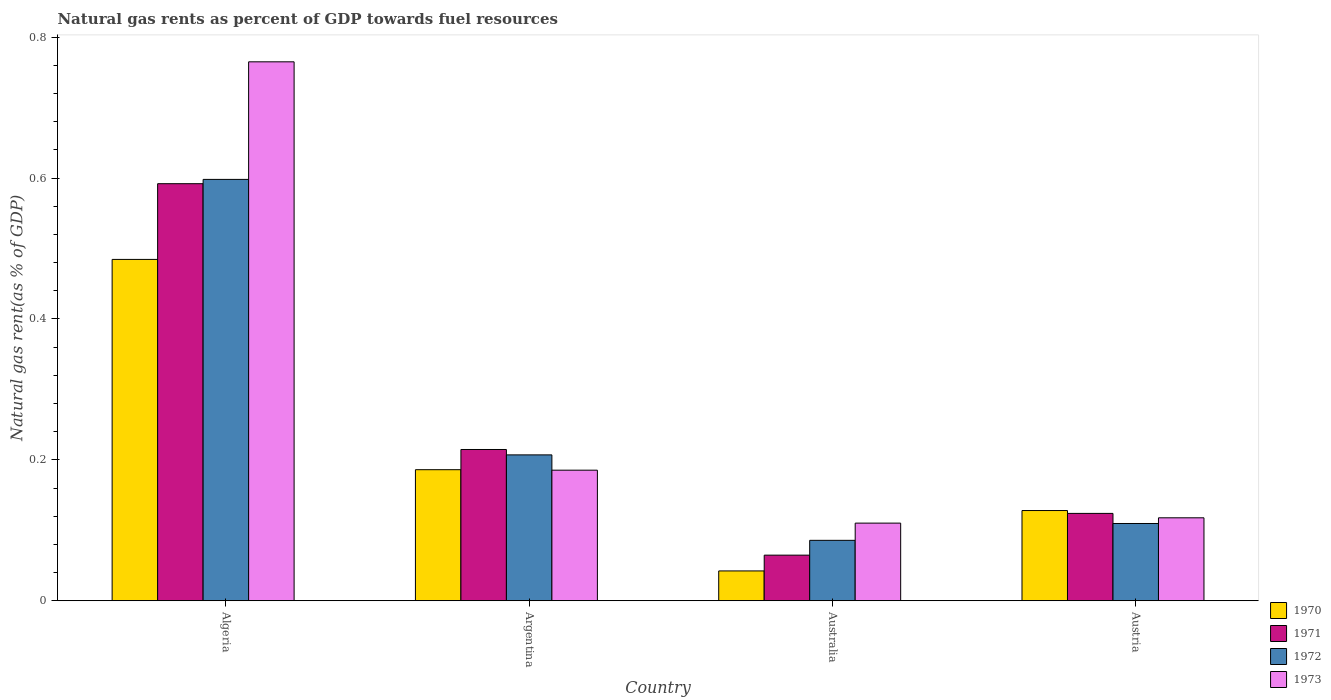Are the number of bars on each tick of the X-axis equal?
Provide a succinct answer. Yes. How many bars are there on the 2nd tick from the left?
Offer a very short reply. 4. What is the label of the 2nd group of bars from the left?
Keep it short and to the point. Argentina. What is the natural gas rent in 1972 in Austria?
Give a very brief answer. 0.11. Across all countries, what is the maximum natural gas rent in 1970?
Your answer should be compact. 0.48. Across all countries, what is the minimum natural gas rent in 1971?
Ensure brevity in your answer.  0.06. In which country was the natural gas rent in 1971 maximum?
Provide a short and direct response. Algeria. What is the total natural gas rent in 1971 in the graph?
Offer a very short reply. 1. What is the difference between the natural gas rent in 1971 in Argentina and that in Australia?
Offer a very short reply. 0.15. What is the difference between the natural gas rent in 1972 in Australia and the natural gas rent in 1970 in Austria?
Your answer should be compact. -0.04. What is the average natural gas rent in 1973 per country?
Your answer should be compact. 0.29. What is the difference between the natural gas rent of/in 1973 and natural gas rent of/in 1971 in Australia?
Offer a very short reply. 0.05. What is the ratio of the natural gas rent in 1972 in Argentina to that in Austria?
Keep it short and to the point. 1.89. Is the natural gas rent in 1972 in Argentina less than that in Austria?
Offer a terse response. No. What is the difference between the highest and the second highest natural gas rent in 1973?
Your answer should be very brief. 0.58. What is the difference between the highest and the lowest natural gas rent in 1970?
Provide a succinct answer. 0.44. In how many countries, is the natural gas rent in 1971 greater than the average natural gas rent in 1971 taken over all countries?
Provide a succinct answer. 1. Is the sum of the natural gas rent in 1970 in Algeria and Argentina greater than the maximum natural gas rent in 1972 across all countries?
Offer a very short reply. Yes. Is it the case that in every country, the sum of the natural gas rent in 1971 and natural gas rent in 1973 is greater than the sum of natural gas rent in 1972 and natural gas rent in 1970?
Your response must be concise. No. Is it the case that in every country, the sum of the natural gas rent in 1973 and natural gas rent in 1972 is greater than the natural gas rent in 1971?
Offer a very short reply. Yes. Are all the bars in the graph horizontal?
Provide a short and direct response. No. What is the difference between two consecutive major ticks on the Y-axis?
Provide a short and direct response. 0.2. Does the graph contain any zero values?
Offer a terse response. No. Does the graph contain grids?
Ensure brevity in your answer.  No. Where does the legend appear in the graph?
Provide a short and direct response. Bottom right. What is the title of the graph?
Ensure brevity in your answer.  Natural gas rents as percent of GDP towards fuel resources. What is the label or title of the Y-axis?
Your response must be concise. Natural gas rent(as % of GDP). What is the Natural gas rent(as % of GDP) of 1970 in Algeria?
Provide a short and direct response. 0.48. What is the Natural gas rent(as % of GDP) in 1971 in Algeria?
Your response must be concise. 0.59. What is the Natural gas rent(as % of GDP) in 1972 in Algeria?
Offer a terse response. 0.6. What is the Natural gas rent(as % of GDP) in 1973 in Algeria?
Your answer should be very brief. 0.76. What is the Natural gas rent(as % of GDP) in 1970 in Argentina?
Provide a short and direct response. 0.19. What is the Natural gas rent(as % of GDP) of 1971 in Argentina?
Offer a terse response. 0.21. What is the Natural gas rent(as % of GDP) of 1972 in Argentina?
Make the answer very short. 0.21. What is the Natural gas rent(as % of GDP) in 1973 in Argentina?
Offer a very short reply. 0.19. What is the Natural gas rent(as % of GDP) in 1970 in Australia?
Offer a very short reply. 0.04. What is the Natural gas rent(as % of GDP) of 1971 in Australia?
Ensure brevity in your answer.  0.06. What is the Natural gas rent(as % of GDP) in 1972 in Australia?
Make the answer very short. 0.09. What is the Natural gas rent(as % of GDP) of 1973 in Australia?
Provide a short and direct response. 0.11. What is the Natural gas rent(as % of GDP) in 1970 in Austria?
Your answer should be compact. 0.13. What is the Natural gas rent(as % of GDP) of 1971 in Austria?
Your response must be concise. 0.12. What is the Natural gas rent(as % of GDP) of 1972 in Austria?
Offer a very short reply. 0.11. What is the Natural gas rent(as % of GDP) in 1973 in Austria?
Your response must be concise. 0.12. Across all countries, what is the maximum Natural gas rent(as % of GDP) in 1970?
Your response must be concise. 0.48. Across all countries, what is the maximum Natural gas rent(as % of GDP) in 1971?
Offer a terse response. 0.59. Across all countries, what is the maximum Natural gas rent(as % of GDP) of 1972?
Your answer should be very brief. 0.6. Across all countries, what is the maximum Natural gas rent(as % of GDP) in 1973?
Provide a succinct answer. 0.76. Across all countries, what is the minimum Natural gas rent(as % of GDP) of 1970?
Give a very brief answer. 0.04. Across all countries, what is the minimum Natural gas rent(as % of GDP) of 1971?
Ensure brevity in your answer.  0.06. Across all countries, what is the minimum Natural gas rent(as % of GDP) of 1972?
Offer a terse response. 0.09. Across all countries, what is the minimum Natural gas rent(as % of GDP) in 1973?
Keep it short and to the point. 0.11. What is the total Natural gas rent(as % of GDP) of 1970 in the graph?
Provide a short and direct response. 0.84. What is the total Natural gas rent(as % of GDP) of 1971 in the graph?
Offer a very short reply. 1. What is the total Natural gas rent(as % of GDP) in 1973 in the graph?
Make the answer very short. 1.18. What is the difference between the Natural gas rent(as % of GDP) of 1970 in Algeria and that in Argentina?
Provide a short and direct response. 0.3. What is the difference between the Natural gas rent(as % of GDP) in 1971 in Algeria and that in Argentina?
Provide a succinct answer. 0.38. What is the difference between the Natural gas rent(as % of GDP) in 1972 in Algeria and that in Argentina?
Offer a terse response. 0.39. What is the difference between the Natural gas rent(as % of GDP) of 1973 in Algeria and that in Argentina?
Offer a terse response. 0.58. What is the difference between the Natural gas rent(as % of GDP) of 1970 in Algeria and that in Australia?
Provide a succinct answer. 0.44. What is the difference between the Natural gas rent(as % of GDP) in 1971 in Algeria and that in Australia?
Your response must be concise. 0.53. What is the difference between the Natural gas rent(as % of GDP) of 1972 in Algeria and that in Australia?
Your response must be concise. 0.51. What is the difference between the Natural gas rent(as % of GDP) in 1973 in Algeria and that in Australia?
Keep it short and to the point. 0.65. What is the difference between the Natural gas rent(as % of GDP) of 1970 in Algeria and that in Austria?
Give a very brief answer. 0.36. What is the difference between the Natural gas rent(as % of GDP) in 1971 in Algeria and that in Austria?
Provide a short and direct response. 0.47. What is the difference between the Natural gas rent(as % of GDP) of 1972 in Algeria and that in Austria?
Offer a very short reply. 0.49. What is the difference between the Natural gas rent(as % of GDP) of 1973 in Algeria and that in Austria?
Provide a succinct answer. 0.65. What is the difference between the Natural gas rent(as % of GDP) of 1970 in Argentina and that in Australia?
Your answer should be compact. 0.14. What is the difference between the Natural gas rent(as % of GDP) in 1971 in Argentina and that in Australia?
Keep it short and to the point. 0.15. What is the difference between the Natural gas rent(as % of GDP) of 1972 in Argentina and that in Australia?
Keep it short and to the point. 0.12. What is the difference between the Natural gas rent(as % of GDP) in 1973 in Argentina and that in Australia?
Offer a terse response. 0.08. What is the difference between the Natural gas rent(as % of GDP) of 1970 in Argentina and that in Austria?
Your response must be concise. 0.06. What is the difference between the Natural gas rent(as % of GDP) of 1971 in Argentina and that in Austria?
Provide a short and direct response. 0.09. What is the difference between the Natural gas rent(as % of GDP) of 1972 in Argentina and that in Austria?
Your response must be concise. 0.1. What is the difference between the Natural gas rent(as % of GDP) of 1973 in Argentina and that in Austria?
Offer a terse response. 0.07. What is the difference between the Natural gas rent(as % of GDP) of 1970 in Australia and that in Austria?
Ensure brevity in your answer.  -0.09. What is the difference between the Natural gas rent(as % of GDP) in 1971 in Australia and that in Austria?
Give a very brief answer. -0.06. What is the difference between the Natural gas rent(as % of GDP) of 1972 in Australia and that in Austria?
Your response must be concise. -0.02. What is the difference between the Natural gas rent(as % of GDP) in 1973 in Australia and that in Austria?
Offer a very short reply. -0.01. What is the difference between the Natural gas rent(as % of GDP) of 1970 in Algeria and the Natural gas rent(as % of GDP) of 1971 in Argentina?
Provide a short and direct response. 0.27. What is the difference between the Natural gas rent(as % of GDP) in 1970 in Algeria and the Natural gas rent(as % of GDP) in 1972 in Argentina?
Offer a terse response. 0.28. What is the difference between the Natural gas rent(as % of GDP) of 1970 in Algeria and the Natural gas rent(as % of GDP) of 1973 in Argentina?
Your response must be concise. 0.3. What is the difference between the Natural gas rent(as % of GDP) in 1971 in Algeria and the Natural gas rent(as % of GDP) in 1972 in Argentina?
Give a very brief answer. 0.38. What is the difference between the Natural gas rent(as % of GDP) of 1971 in Algeria and the Natural gas rent(as % of GDP) of 1973 in Argentina?
Provide a succinct answer. 0.41. What is the difference between the Natural gas rent(as % of GDP) of 1972 in Algeria and the Natural gas rent(as % of GDP) of 1973 in Argentina?
Provide a short and direct response. 0.41. What is the difference between the Natural gas rent(as % of GDP) in 1970 in Algeria and the Natural gas rent(as % of GDP) in 1971 in Australia?
Give a very brief answer. 0.42. What is the difference between the Natural gas rent(as % of GDP) in 1970 in Algeria and the Natural gas rent(as % of GDP) in 1972 in Australia?
Provide a short and direct response. 0.4. What is the difference between the Natural gas rent(as % of GDP) in 1970 in Algeria and the Natural gas rent(as % of GDP) in 1973 in Australia?
Your answer should be very brief. 0.37. What is the difference between the Natural gas rent(as % of GDP) in 1971 in Algeria and the Natural gas rent(as % of GDP) in 1972 in Australia?
Provide a short and direct response. 0.51. What is the difference between the Natural gas rent(as % of GDP) of 1971 in Algeria and the Natural gas rent(as % of GDP) of 1973 in Australia?
Provide a succinct answer. 0.48. What is the difference between the Natural gas rent(as % of GDP) of 1972 in Algeria and the Natural gas rent(as % of GDP) of 1973 in Australia?
Make the answer very short. 0.49. What is the difference between the Natural gas rent(as % of GDP) in 1970 in Algeria and the Natural gas rent(as % of GDP) in 1971 in Austria?
Make the answer very short. 0.36. What is the difference between the Natural gas rent(as % of GDP) of 1970 in Algeria and the Natural gas rent(as % of GDP) of 1972 in Austria?
Ensure brevity in your answer.  0.37. What is the difference between the Natural gas rent(as % of GDP) in 1970 in Algeria and the Natural gas rent(as % of GDP) in 1973 in Austria?
Give a very brief answer. 0.37. What is the difference between the Natural gas rent(as % of GDP) of 1971 in Algeria and the Natural gas rent(as % of GDP) of 1972 in Austria?
Give a very brief answer. 0.48. What is the difference between the Natural gas rent(as % of GDP) of 1971 in Algeria and the Natural gas rent(as % of GDP) of 1973 in Austria?
Ensure brevity in your answer.  0.47. What is the difference between the Natural gas rent(as % of GDP) of 1972 in Algeria and the Natural gas rent(as % of GDP) of 1973 in Austria?
Provide a short and direct response. 0.48. What is the difference between the Natural gas rent(as % of GDP) of 1970 in Argentina and the Natural gas rent(as % of GDP) of 1971 in Australia?
Offer a very short reply. 0.12. What is the difference between the Natural gas rent(as % of GDP) in 1970 in Argentina and the Natural gas rent(as % of GDP) in 1972 in Australia?
Make the answer very short. 0.1. What is the difference between the Natural gas rent(as % of GDP) of 1970 in Argentina and the Natural gas rent(as % of GDP) of 1973 in Australia?
Provide a short and direct response. 0.08. What is the difference between the Natural gas rent(as % of GDP) in 1971 in Argentina and the Natural gas rent(as % of GDP) in 1972 in Australia?
Your response must be concise. 0.13. What is the difference between the Natural gas rent(as % of GDP) of 1971 in Argentina and the Natural gas rent(as % of GDP) of 1973 in Australia?
Provide a succinct answer. 0.1. What is the difference between the Natural gas rent(as % of GDP) in 1972 in Argentina and the Natural gas rent(as % of GDP) in 1973 in Australia?
Your answer should be compact. 0.1. What is the difference between the Natural gas rent(as % of GDP) of 1970 in Argentina and the Natural gas rent(as % of GDP) of 1971 in Austria?
Your answer should be very brief. 0.06. What is the difference between the Natural gas rent(as % of GDP) of 1970 in Argentina and the Natural gas rent(as % of GDP) of 1972 in Austria?
Offer a very short reply. 0.08. What is the difference between the Natural gas rent(as % of GDP) in 1970 in Argentina and the Natural gas rent(as % of GDP) in 1973 in Austria?
Keep it short and to the point. 0.07. What is the difference between the Natural gas rent(as % of GDP) in 1971 in Argentina and the Natural gas rent(as % of GDP) in 1972 in Austria?
Offer a terse response. 0.1. What is the difference between the Natural gas rent(as % of GDP) of 1971 in Argentina and the Natural gas rent(as % of GDP) of 1973 in Austria?
Ensure brevity in your answer.  0.1. What is the difference between the Natural gas rent(as % of GDP) of 1972 in Argentina and the Natural gas rent(as % of GDP) of 1973 in Austria?
Provide a short and direct response. 0.09. What is the difference between the Natural gas rent(as % of GDP) of 1970 in Australia and the Natural gas rent(as % of GDP) of 1971 in Austria?
Provide a succinct answer. -0.08. What is the difference between the Natural gas rent(as % of GDP) in 1970 in Australia and the Natural gas rent(as % of GDP) in 1972 in Austria?
Your answer should be very brief. -0.07. What is the difference between the Natural gas rent(as % of GDP) of 1970 in Australia and the Natural gas rent(as % of GDP) of 1973 in Austria?
Your response must be concise. -0.08. What is the difference between the Natural gas rent(as % of GDP) in 1971 in Australia and the Natural gas rent(as % of GDP) in 1972 in Austria?
Keep it short and to the point. -0.04. What is the difference between the Natural gas rent(as % of GDP) of 1971 in Australia and the Natural gas rent(as % of GDP) of 1973 in Austria?
Keep it short and to the point. -0.05. What is the difference between the Natural gas rent(as % of GDP) in 1972 in Australia and the Natural gas rent(as % of GDP) in 1973 in Austria?
Ensure brevity in your answer.  -0.03. What is the average Natural gas rent(as % of GDP) of 1970 per country?
Ensure brevity in your answer.  0.21. What is the average Natural gas rent(as % of GDP) of 1971 per country?
Ensure brevity in your answer.  0.25. What is the average Natural gas rent(as % of GDP) in 1972 per country?
Offer a terse response. 0.25. What is the average Natural gas rent(as % of GDP) of 1973 per country?
Provide a short and direct response. 0.29. What is the difference between the Natural gas rent(as % of GDP) of 1970 and Natural gas rent(as % of GDP) of 1971 in Algeria?
Give a very brief answer. -0.11. What is the difference between the Natural gas rent(as % of GDP) in 1970 and Natural gas rent(as % of GDP) in 1972 in Algeria?
Offer a very short reply. -0.11. What is the difference between the Natural gas rent(as % of GDP) in 1970 and Natural gas rent(as % of GDP) in 1973 in Algeria?
Your answer should be very brief. -0.28. What is the difference between the Natural gas rent(as % of GDP) of 1971 and Natural gas rent(as % of GDP) of 1972 in Algeria?
Keep it short and to the point. -0.01. What is the difference between the Natural gas rent(as % of GDP) in 1971 and Natural gas rent(as % of GDP) in 1973 in Algeria?
Make the answer very short. -0.17. What is the difference between the Natural gas rent(as % of GDP) of 1972 and Natural gas rent(as % of GDP) of 1973 in Algeria?
Keep it short and to the point. -0.17. What is the difference between the Natural gas rent(as % of GDP) in 1970 and Natural gas rent(as % of GDP) in 1971 in Argentina?
Offer a very short reply. -0.03. What is the difference between the Natural gas rent(as % of GDP) of 1970 and Natural gas rent(as % of GDP) of 1972 in Argentina?
Ensure brevity in your answer.  -0.02. What is the difference between the Natural gas rent(as % of GDP) of 1970 and Natural gas rent(as % of GDP) of 1973 in Argentina?
Give a very brief answer. 0. What is the difference between the Natural gas rent(as % of GDP) of 1971 and Natural gas rent(as % of GDP) of 1972 in Argentina?
Your response must be concise. 0.01. What is the difference between the Natural gas rent(as % of GDP) of 1971 and Natural gas rent(as % of GDP) of 1973 in Argentina?
Your answer should be compact. 0.03. What is the difference between the Natural gas rent(as % of GDP) in 1972 and Natural gas rent(as % of GDP) in 1973 in Argentina?
Give a very brief answer. 0.02. What is the difference between the Natural gas rent(as % of GDP) in 1970 and Natural gas rent(as % of GDP) in 1971 in Australia?
Give a very brief answer. -0.02. What is the difference between the Natural gas rent(as % of GDP) of 1970 and Natural gas rent(as % of GDP) of 1972 in Australia?
Offer a terse response. -0.04. What is the difference between the Natural gas rent(as % of GDP) in 1970 and Natural gas rent(as % of GDP) in 1973 in Australia?
Offer a very short reply. -0.07. What is the difference between the Natural gas rent(as % of GDP) of 1971 and Natural gas rent(as % of GDP) of 1972 in Australia?
Provide a short and direct response. -0.02. What is the difference between the Natural gas rent(as % of GDP) of 1971 and Natural gas rent(as % of GDP) of 1973 in Australia?
Provide a succinct answer. -0.05. What is the difference between the Natural gas rent(as % of GDP) of 1972 and Natural gas rent(as % of GDP) of 1973 in Australia?
Your response must be concise. -0.02. What is the difference between the Natural gas rent(as % of GDP) in 1970 and Natural gas rent(as % of GDP) in 1971 in Austria?
Keep it short and to the point. 0. What is the difference between the Natural gas rent(as % of GDP) in 1970 and Natural gas rent(as % of GDP) in 1972 in Austria?
Provide a short and direct response. 0.02. What is the difference between the Natural gas rent(as % of GDP) in 1970 and Natural gas rent(as % of GDP) in 1973 in Austria?
Your answer should be very brief. 0.01. What is the difference between the Natural gas rent(as % of GDP) of 1971 and Natural gas rent(as % of GDP) of 1972 in Austria?
Your answer should be very brief. 0.01. What is the difference between the Natural gas rent(as % of GDP) in 1971 and Natural gas rent(as % of GDP) in 1973 in Austria?
Make the answer very short. 0.01. What is the difference between the Natural gas rent(as % of GDP) in 1972 and Natural gas rent(as % of GDP) in 1973 in Austria?
Provide a short and direct response. -0.01. What is the ratio of the Natural gas rent(as % of GDP) in 1970 in Algeria to that in Argentina?
Make the answer very short. 2.6. What is the ratio of the Natural gas rent(as % of GDP) of 1971 in Algeria to that in Argentina?
Your answer should be compact. 2.76. What is the ratio of the Natural gas rent(as % of GDP) in 1972 in Algeria to that in Argentina?
Your response must be concise. 2.89. What is the ratio of the Natural gas rent(as % of GDP) in 1973 in Algeria to that in Argentina?
Make the answer very short. 4.13. What is the ratio of the Natural gas rent(as % of GDP) in 1970 in Algeria to that in Australia?
Provide a short and direct response. 11.44. What is the ratio of the Natural gas rent(as % of GDP) of 1971 in Algeria to that in Australia?
Your answer should be compact. 9.14. What is the ratio of the Natural gas rent(as % of GDP) in 1972 in Algeria to that in Australia?
Give a very brief answer. 6.97. What is the ratio of the Natural gas rent(as % of GDP) in 1973 in Algeria to that in Australia?
Make the answer very short. 6.94. What is the ratio of the Natural gas rent(as % of GDP) of 1970 in Algeria to that in Austria?
Offer a very short reply. 3.78. What is the ratio of the Natural gas rent(as % of GDP) in 1971 in Algeria to that in Austria?
Your answer should be compact. 4.77. What is the ratio of the Natural gas rent(as % of GDP) of 1972 in Algeria to that in Austria?
Your response must be concise. 5.45. What is the ratio of the Natural gas rent(as % of GDP) in 1973 in Algeria to that in Austria?
Give a very brief answer. 6.5. What is the ratio of the Natural gas rent(as % of GDP) in 1970 in Argentina to that in Australia?
Provide a succinct answer. 4.39. What is the ratio of the Natural gas rent(as % of GDP) of 1971 in Argentina to that in Australia?
Keep it short and to the point. 3.32. What is the ratio of the Natural gas rent(as % of GDP) of 1972 in Argentina to that in Australia?
Make the answer very short. 2.41. What is the ratio of the Natural gas rent(as % of GDP) in 1973 in Argentina to that in Australia?
Your response must be concise. 1.68. What is the ratio of the Natural gas rent(as % of GDP) of 1970 in Argentina to that in Austria?
Provide a short and direct response. 1.45. What is the ratio of the Natural gas rent(as % of GDP) of 1971 in Argentina to that in Austria?
Offer a terse response. 1.73. What is the ratio of the Natural gas rent(as % of GDP) in 1972 in Argentina to that in Austria?
Give a very brief answer. 1.89. What is the ratio of the Natural gas rent(as % of GDP) of 1973 in Argentina to that in Austria?
Give a very brief answer. 1.57. What is the ratio of the Natural gas rent(as % of GDP) of 1970 in Australia to that in Austria?
Give a very brief answer. 0.33. What is the ratio of the Natural gas rent(as % of GDP) of 1971 in Australia to that in Austria?
Your response must be concise. 0.52. What is the ratio of the Natural gas rent(as % of GDP) in 1972 in Australia to that in Austria?
Give a very brief answer. 0.78. What is the ratio of the Natural gas rent(as % of GDP) in 1973 in Australia to that in Austria?
Offer a terse response. 0.94. What is the difference between the highest and the second highest Natural gas rent(as % of GDP) of 1970?
Provide a succinct answer. 0.3. What is the difference between the highest and the second highest Natural gas rent(as % of GDP) in 1971?
Give a very brief answer. 0.38. What is the difference between the highest and the second highest Natural gas rent(as % of GDP) in 1972?
Keep it short and to the point. 0.39. What is the difference between the highest and the second highest Natural gas rent(as % of GDP) in 1973?
Make the answer very short. 0.58. What is the difference between the highest and the lowest Natural gas rent(as % of GDP) in 1970?
Your answer should be very brief. 0.44. What is the difference between the highest and the lowest Natural gas rent(as % of GDP) of 1971?
Provide a short and direct response. 0.53. What is the difference between the highest and the lowest Natural gas rent(as % of GDP) in 1972?
Your response must be concise. 0.51. What is the difference between the highest and the lowest Natural gas rent(as % of GDP) in 1973?
Provide a succinct answer. 0.65. 